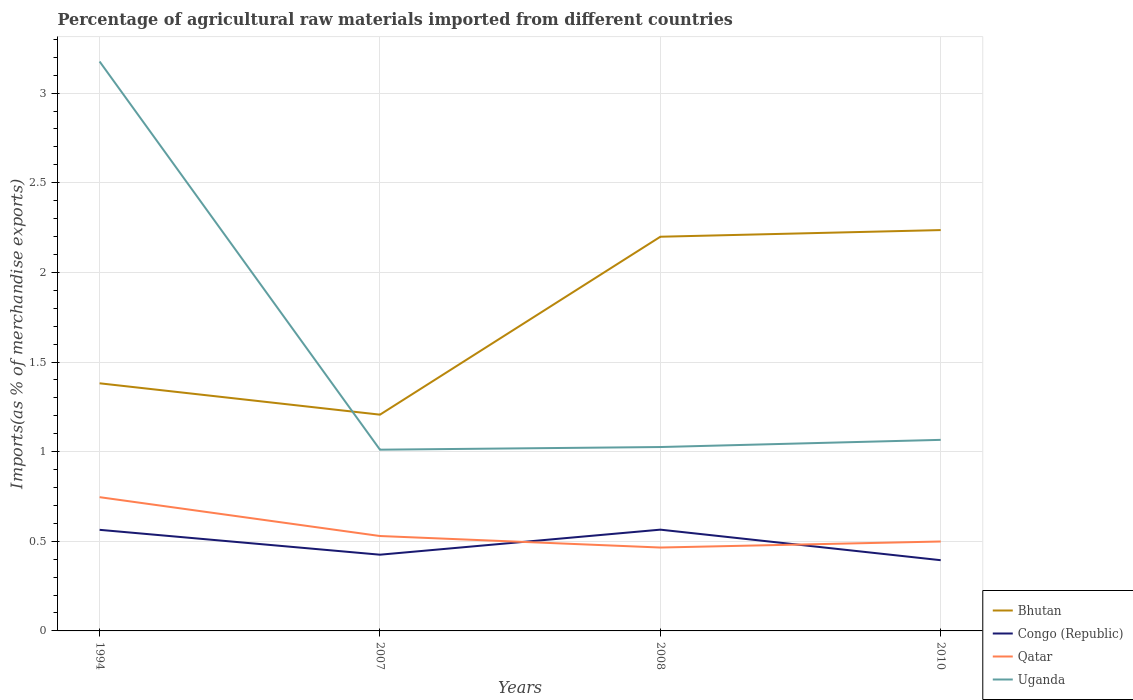Is the number of lines equal to the number of legend labels?
Your answer should be very brief. Yes. Across all years, what is the maximum percentage of imports to different countries in Qatar?
Provide a short and direct response. 0.47. In which year was the percentage of imports to different countries in Uganda maximum?
Make the answer very short. 2007. What is the total percentage of imports to different countries in Qatar in the graph?
Provide a succinct answer. 0.28. What is the difference between the highest and the second highest percentage of imports to different countries in Congo (Republic)?
Your answer should be compact. 0.17. How many lines are there?
Make the answer very short. 4. How many years are there in the graph?
Provide a short and direct response. 4. What is the difference between two consecutive major ticks on the Y-axis?
Provide a short and direct response. 0.5. How are the legend labels stacked?
Provide a succinct answer. Vertical. What is the title of the graph?
Offer a very short reply. Percentage of agricultural raw materials imported from different countries. Does "Hong Kong" appear as one of the legend labels in the graph?
Provide a short and direct response. No. What is the label or title of the X-axis?
Give a very brief answer. Years. What is the label or title of the Y-axis?
Keep it short and to the point. Imports(as % of merchandise exports). What is the Imports(as % of merchandise exports) in Bhutan in 1994?
Give a very brief answer. 1.38. What is the Imports(as % of merchandise exports) of Congo (Republic) in 1994?
Make the answer very short. 0.56. What is the Imports(as % of merchandise exports) in Qatar in 1994?
Give a very brief answer. 0.75. What is the Imports(as % of merchandise exports) of Uganda in 1994?
Offer a terse response. 3.18. What is the Imports(as % of merchandise exports) of Bhutan in 2007?
Provide a short and direct response. 1.21. What is the Imports(as % of merchandise exports) in Congo (Republic) in 2007?
Offer a terse response. 0.43. What is the Imports(as % of merchandise exports) of Qatar in 2007?
Provide a short and direct response. 0.53. What is the Imports(as % of merchandise exports) of Uganda in 2007?
Provide a succinct answer. 1.01. What is the Imports(as % of merchandise exports) of Bhutan in 2008?
Your answer should be compact. 2.2. What is the Imports(as % of merchandise exports) in Congo (Republic) in 2008?
Make the answer very short. 0.56. What is the Imports(as % of merchandise exports) in Qatar in 2008?
Give a very brief answer. 0.47. What is the Imports(as % of merchandise exports) of Uganda in 2008?
Provide a short and direct response. 1.03. What is the Imports(as % of merchandise exports) of Bhutan in 2010?
Provide a succinct answer. 2.24. What is the Imports(as % of merchandise exports) of Congo (Republic) in 2010?
Your response must be concise. 0.39. What is the Imports(as % of merchandise exports) of Qatar in 2010?
Keep it short and to the point. 0.5. What is the Imports(as % of merchandise exports) in Uganda in 2010?
Offer a very short reply. 1.07. Across all years, what is the maximum Imports(as % of merchandise exports) in Bhutan?
Provide a succinct answer. 2.24. Across all years, what is the maximum Imports(as % of merchandise exports) of Congo (Republic)?
Offer a terse response. 0.56. Across all years, what is the maximum Imports(as % of merchandise exports) in Qatar?
Offer a terse response. 0.75. Across all years, what is the maximum Imports(as % of merchandise exports) of Uganda?
Provide a short and direct response. 3.18. Across all years, what is the minimum Imports(as % of merchandise exports) of Bhutan?
Give a very brief answer. 1.21. Across all years, what is the minimum Imports(as % of merchandise exports) of Congo (Republic)?
Offer a terse response. 0.39. Across all years, what is the minimum Imports(as % of merchandise exports) of Qatar?
Your answer should be very brief. 0.47. Across all years, what is the minimum Imports(as % of merchandise exports) in Uganda?
Make the answer very short. 1.01. What is the total Imports(as % of merchandise exports) of Bhutan in the graph?
Your answer should be compact. 7.02. What is the total Imports(as % of merchandise exports) of Congo (Republic) in the graph?
Your response must be concise. 1.95. What is the total Imports(as % of merchandise exports) of Qatar in the graph?
Ensure brevity in your answer.  2.24. What is the total Imports(as % of merchandise exports) in Uganda in the graph?
Make the answer very short. 6.28. What is the difference between the Imports(as % of merchandise exports) of Bhutan in 1994 and that in 2007?
Make the answer very short. 0.17. What is the difference between the Imports(as % of merchandise exports) of Congo (Republic) in 1994 and that in 2007?
Your answer should be compact. 0.14. What is the difference between the Imports(as % of merchandise exports) of Qatar in 1994 and that in 2007?
Make the answer very short. 0.22. What is the difference between the Imports(as % of merchandise exports) in Uganda in 1994 and that in 2007?
Make the answer very short. 2.17. What is the difference between the Imports(as % of merchandise exports) of Bhutan in 1994 and that in 2008?
Your response must be concise. -0.82. What is the difference between the Imports(as % of merchandise exports) of Congo (Republic) in 1994 and that in 2008?
Offer a terse response. -0. What is the difference between the Imports(as % of merchandise exports) of Qatar in 1994 and that in 2008?
Your answer should be compact. 0.28. What is the difference between the Imports(as % of merchandise exports) of Uganda in 1994 and that in 2008?
Your response must be concise. 2.15. What is the difference between the Imports(as % of merchandise exports) of Bhutan in 1994 and that in 2010?
Keep it short and to the point. -0.85. What is the difference between the Imports(as % of merchandise exports) in Congo (Republic) in 1994 and that in 2010?
Give a very brief answer. 0.17. What is the difference between the Imports(as % of merchandise exports) in Qatar in 1994 and that in 2010?
Provide a short and direct response. 0.25. What is the difference between the Imports(as % of merchandise exports) in Uganda in 1994 and that in 2010?
Your answer should be very brief. 2.11. What is the difference between the Imports(as % of merchandise exports) in Bhutan in 2007 and that in 2008?
Make the answer very short. -0.99. What is the difference between the Imports(as % of merchandise exports) of Congo (Republic) in 2007 and that in 2008?
Ensure brevity in your answer.  -0.14. What is the difference between the Imports(as % of merchandise exports) in Qatar in 2007 and that in 2008?
Your answer should be very brief. 0.06. What is the difference between the Imports(as % of merchandise exports) in Uganda in 2007 and that in 2008?
Ensure brevity in your answer.  -0.01. What is the difference between the Imports(as % of merchandise exports) in Bhutan in 2007 and that in 2010?
Your answer should be compact. -1.03. What is the difference between the Imports(as % of merchandise exports) of Congo (Republic) in 2007 and that in 2010?
Ensure brevity in your answer.  0.03. What is the difference between the Imports(as % of merchandise exports) in Qatar in 2007 and that in 2010?
Your answer should be very brief. 0.03. What is the difference between the Imports(as % of merchandise exports) of Uganda in 2007 and that in 2010?
Offer a very short reply. -0.05. What is the difference between the Imports(as % of merchandise exports) in Bhutan in 2008 and that in 2010?
Offer a very short reply. -0.04. What is the difference between the Imports(as % of merchandise exports) of Congo (Republic) in 2008 and that in 2010?
Keep it short and to the point. 0.17. What is the difference between the Imports(as % of merchandise exports) of Qatar in 2008 and that in 2010?
Keep it short and to the point. -0.03. What is the difference between the Imports(as % of merchandise exports) of Uganda in 2008 and that in 2010?
Provide a short and direct response. -0.04. What is the difference between the Imports(as % of merchandise exports) of Bhutan in 1994 and the Imports(as % of merchandise exports) of Congo (Republic) in 2007?
Make the answer very short. 0.96. What is the difference between the Imports(as % of merchandise exports) of Bhutan in 1994 and the Imports(as % of merchandise exports) of Qatar in 2007?
Ensure brevity in your answer.  0.85. What is the difference between the Imports(as % of merchandise exports) of Bhutan in 1994 and the Imports(as % of merchandise exports) of Uganda in 2007?
Provide a succinct answer. 0.37. What is the difference between the Imports(as % of merchandise exports) in Congo (Republic) in 1994 and the Imports(as % of merchandise exports) in Qatar in 2007?
Offer a terse response. 0.03. What is the difference between the Imports(as % of merchandise exports) in Congo (Republic) in 1994 and the Imports(as % of merchandise exports) in Uganda in 2007?
Provide a short and direct response. -0.45. What is the difference between the Imports(as % of merchandise exports) of Qatar in 1994 and the Imports(as % of merchandise exports) of Uganda in 2007?
Keep it short and to the point. -0.26. What is the difference between the Imports(as % of merchandise exports) of Bhutan in 1994 and the Imports(as % of merchandise exports) of Congo (Republic) in 2008?
Provide a succinct answer. 0.82. What is the difference between the Imports(as % of merchandise exports) in Bhutan in 1994 and the Imports(as % of merchandise exports) in Qatar in 2008?
Your response must be concise. 0.92. What is the difference between the Imports(as % of merchandise exports) of Bhutan in 1994 and the Imports(as % of merchandise exports) of Uganda in 2008?
Your answer should be very brief. 0.36. What is the difference between the Imports(as % of merchandise exports) in Congo (Republic) in 1994 and the Imports(as % of merchandise exports) in Qatar in 2008?
Your response must be concise. 0.1. What is the difference between the Imports(as % of merchandise exports) in Congo (Republic) in 1994 and the Imports(as % of merchandise exports) in Uganda in 2008?
Provide a short and direct response. -0.46. What is the difference between the Imports(as % of merchandise exports) in Qatar in 1994 and the Imports(as % of merchandise exports) in Uganda in 2008?
Provide a short and direct response. -0.28. What is the difference between the Imports(as % of merchandise exports) in Bhutan in 1994 and the Imports(as % of merchandise exports) in Qatar in 2010?
Give a very brief answer. 0.88. What is the difference between the Imports(as % of merchandise exports) of Bhutan in 1994 and the Imports(as % of merchandise exports) of Uganda in 2010?
Your answer should be compact. 0.32. What is the difference between the Imports(as % of merchandise exports) in Congo (Republic) in 1994 and the Imports(as % of merchandise exports) in Qatar in 2010?
Provide a short and direct response. 0.07. What is the difference between the Imports(as % of merchandise exports) in Congo (Republic) in 1994 and the Imports(as % of merchandise exports) in Uganda in 2010?
Your answer should be very brief. -0.5. What is the difference between the Imports(as % of merchandise exports) in Qatar in 1994 and the Imports(as % of merchandise exports) in Uganda in 2010?
Provide a succinct answer. -0.32. What is the difference between the Imports(as % of merchandise exports) in Bhutan in 2007 and the Imports(as % of merchandise exports) in Congo (Republic) in 2008?
Provide a succinct answer. 0.64. What is the difference between the Imports(as % of merchandise exports) of Bhutan in 2007 and the Imports(as % of merchandise exports) of Qatar in 2008?
Your response must be concise. 0.74. What is the difference between the Imports(as % of merchandise exports) of Bhutan in 2007 and the Imports(as % of merchandise exports) of Uganda in 2008?
Keep it short and to the point. 0.18. What is the difference between the Imports(as % of merchandise exports) of Congo (Republic) in 2007 and the Imports(as % of merchandise exports) of Qatar in 2008?
Provide a short and direct response. -0.04. What is the difference between the Imports(as % of merchandise exports) in Congo (Republic) in 2007 and the Imports(as % of merchandise exports) in Uganda in 2008?
Your response must be concise. -0.6. What is the difference between the Imports(as % of merchandise exports) of Qatar in 2007 and the Imports(as % of merchandise exports) of Uganda in 2008?
Make the answer very short. -0.5. What is the difference between the Imports(as % of merchandise exports) in Bhutan in 2007 and the Imports(as % of merchandise exports) in Congo (Republic) in 2010?
Offer a terse response. 0.81. What is the difference between the Imports(as % of merchandise exports) in Bhutan in 2007 and the Imports(as % of merchandise exports) in Qatar in 2010?
Your answer should be compact. 0.71. What is the difference between the Imports(as % of merchandise exports) of Bhutan in 2007 and the Imports(as % of merchandise exports) of Uganda in 2010?
Offer a terse response. 0.14. What is the difference between the Imports(as % of merchandise exports) in Congo (Republic) in 2007 and the Imports(as % of merchandise exports) in Qatar in 2010?
Keep it short and to the point. -0.07. What is the difference between the Imports(as % of merchandise exports) in Congo (Republic) in 2007 and the Imports(as % of merchandise exports) in Uganda in 2010?
Offer a very short reply. -0.64. What is the difference between the Imports(as % of merchandise exports) in Qatar in 2007 and the Imports(as % of merchandise exports) in Uganda in 2010?
Your response must be concise. -0.54. What is the difference between the Imports(as % of merchandise exports) in Bhutan in 2008 and the Imports(as % of merchandise exports) in Congo (Republic) in 2010?
Provide a short and direct response. 1.8. What is the difference between the Imports(as % of merchandise exports) in Bhutan in 2008 and the Imports(as % of merchandise exports) in Uganda in 2010?
Give a very brief answer. 1.13. What is the difference between the Imports(as % of merchandise exports) of Congo (Republic) in 2008 and the Imports(as % of merchandise exports) of Qatar in 2010?
Make the answer very short. 0.07. What is the difference between the Imports(as % of merchandise exports) of Congo (Republic) in 2008 and the Imports(as % of merchandise exports) of Uganda in 2010?
Make the answer very short. -0.5. What is the difference between the Imports(as % of merchandise exports) of Qatar in 2008 and the Imports(as % of merchandise exports) of Uganda in 2010?
Keep it short and to the point. -0.6. What is the average Imports(as % of merchandise exports) of Bhutan per year?
Provide a short and direct response. 1.76. What is the average Imports(as % of merchandise exports) in Congo (Republic) per year?
Your response must be concise. 0.49. What is the average Imports(as % of merchandise exports) in Qatar per year?
Offer a very short reply. 0.56. What is the average Imports(as % of merchandise exports) in Uganda per year?
Your answer should be very brief. 1.57. In the year 1994, what is the difference between the Imports(as % of merchandise exports) of Bhutan and Imports(as % of merchandise exports) of Congo (Republic)?
Provide a succinct answer. 0.82. In the year 1994, what is the difference between the Imports(as % of merchandise exports) of Bhutan and Imports(as % of merchandise exports) of Qatar?
Your response must be concise. 0.64. In the year 1994, what is the difference between the Imports(as % of merchandise exports) of Bhutan and Imports(as % of merchandise exports) of Uganda?
Provide a succinct answer. -1.79. In the year 1994, what is the difference between the Imports(as % of merchandise exports) of Congo (Republic) and Imports(as % of merchandise exports) of Qatar?
Your answer should be very brief. -0.18. In the year 1994, what is the difference between the Imports(as % of merchandise exports) of Congo (Republic) and Imports(as % of merchandise exports) of Uganda?
Your answer should be very brief. -2.61. In the year 1994, what is the difference between the Imports(as % of merchandise exports) in Qatar and Imports(as % of merchandise exports) in Uganda?
Make the answer very short. -2.43. In the year 2007, what is the difference between the Imports(as % of merchandise exports) in Bhutan and Imports(as % of merchandise exports) in Congo (Republic)?
Your answer should be compact. 0.78. In the year 2007, what is the difference between the Imports(as % of merchandise exports) in Bhutan and Imports(as % of merchandise exports) in Qatar?
Ensure brevity in your answer.  0.68. In the year 2007, what is the difference between the Imports(as % of merchandise exports) of Bhutan and Imports(as % of merchandise exports) of Uganda?
Offer a very short reply. 0.2. In the year 2007, what is the difference between the Imports(as % of merchandise exports) of Congo (Republic) and Imports(as % of merchandise exports) of Qatar?
Your response must be concise. -0.1. In the year 2007, what is the difference between the Imports(as % of merchandise exports) of Congo (Republic) and Imports(as % of merchandise exports) of Uganda?
Provide a succinct answer. -0.59. In the year 2007, what is the difference between the Imports(as % of merchandise exports) of Qatar and Imports(as % of merchandise exports) of Uganda?
Provide a succinct answer. -0.48. In the year 2008, what is the difference between the Imports(as % of merchandise exports) in Bhutan and Imports(as % of merchandise exports) in Congo (Republic)?
Offer a very short reply. 1.63. In the year 2008, what is the difference between the Imports(as % of merchandise exports) in Bhutan and Imports(as % of merchandise exports) in Qatar?
Your response must be concise. 1.73. In the year 2008, what is the difference between the Imports(as % of merchandise exports) in Bhutan and Imports(as % of merchandise exports) in Uganda?
Your response must be concise. 1.17. In the year 2008, what is the difference between the Imports(as % of merchandise exports) in Congo (Republic) and Imports(as % of merchandise exports) in Qatar?
Offer a very short reply. 0.1. In the year 2008, what is the difference between the Imports(as % of merchandise exports) in Congo (Republic) and Imports(as % of merchandise exports) in Uganda?
Your answer should be compact. -0.46. In the year 2008, what is the difference between the Imports(as % of merchandise exports) in Qatar and Imports(as % of merchandise exports) in Uganda?
Ensure brevity in your answer.  -0.56. In the year 2010, what is the difference between the Imports(as % of merchandise exports) of Bhutan and Imports(as % of merchandise exports) of Congo (Republic)?
Provide a succinct answer. 1.84. In the year 2010, what is the difference between the Imports(as % of merchandise exports) in Bhutan and Imports(as % of merchandise exports) in Qatar?
Your response must be concise. 1.74. In the year 2010, what is the difference between the Imports(as % of merchandise exports) in Bhutan and Imports(as % of merchandise exports) in Uganda?
Ensure brevity in your answer.  1.17. In the year 2010, what is the difference between the Imports(as % of merchandise exports) in Congo (Republic) and Imports(as % of merchandise exports) in Qatar?
Your response must be concise. -0.1. In the year 2010, what is the difference between the Imports(as % of merchandise exports) of Congo (Republic) and Imports(as % of merchandise exports) of Uganda?
Ensure brevity in your answer.  -0.67. In the year 2010, what is the difference between the Imports(as % of merchandise exports) of Qatar and Imports(as % of merchandise exports) of Uganda?
Your answer should be compact. -0.57. What is the ratio of the Imports(as % of merchandise exports) in Bhutan in 1994 to that in 2007?
Provide a succinct answer. 1.15. What is the ratio of the Imports(as % of merchandise exports) of Congo (Republic) in 1994 to that in 2007?
Your answer should be compact. 1.33. What is the ratio of the Imports(as % of merchandise exports) in Qatar in 1994 to that in 2007?
Offer a terse response. 1.41. What is the ratio of the Imports(as % of merchandise exports) in Uganda in 1994 to that in 2007?
Keep it short and to the point. 3.14. What is the ratio of the Imports(as % of merchandise exports) in Bhutan in 1994 to that in 2008?
Offer a very short reply. 0.63. What is the ratio of the Imports(as % of merchandise exports) of Qatar in 1994 to that in 2008?
Your answer should be compact. 1.6. What is the ratio of the Imports(as % of merchandise exports) in Uganda in 1994 to that in 2008?
Offer a very short reply. 3.1. What is the ratio of the Imports(as % of merchandise exports) of Bhutan in 1994 to that in 2010?
Offer a terse response. 0.62. What is the ratio of the Imports(as % of merchandise exports) in Congo (Republic) in 1994 to that in 2010?
Keep it short and to the point. 1.43. What is the ratio of the Imports(as % of merchandise exports) of Qatar in 1994 to that in 2010?
Make the answer very short. 1.5. What is the ratio of the Imports(as % of merchandise exports) of Uganda in 1994 to that in 2010?
Your response must be concise. 2.98. What is the ratio of the Imports(as % of merchandise exports) of Bhutan in 2007 to that in 2008?
Provide a succinct answer. 0.55. What is the ratio of the Imports(as % of merchandise exports) of Congo (Republic) in 2007 to that in 2008?
Make the answer very short. 0.75. What is the ratio of the Imports(as % of merchandise exports) in Qatar in 2007 to that in 2008?
Your answer should be compact. 1.14. What is the ratio of the Imports(as % of merchandise exports) in Uganda in 2007 to that in 2008?
Offer a terse response. 0.99. What is the ratio of the Imports(as % of merchandise exports) in Bhutan in 2007 to that in 2010?
Make the answer very short. 0.54. What is the ratio of the Imports(as % of merchandise exports) in Congo (Republic) in 2007 to that in 2010?
Make the answer very short. 1.08. What is the ratio of the Imports(as % of merchandise exports) of Qatar in 2007 to that in 2010?
Give a very brief answer. 1.06. What is the ratio of the Imports(as % of merchandise exports) of Uganda in 2007 to that in 2010?
Your answer should be compact. 0.95. What is the ratio of the Imports(as % of merchandise exports) of Bhutan in 2008 to that in 2010?
Ensure brevity in your answer.  0.98. What is the ratio of the Imports(as % of merchandise exports) of Congo (Republic) in 2008 to that in 2010?
Offer a terse response. 1.43. What is the ratio of the Imports(as % of merchandise exports) in Qatar in 2008 to that in 2010?
Keep it short and to the point. 0.93. What is the ratio of the Imports(as % of merchandise exports) in Uganda in 2008 to that in 2010?
Ensure brevity in your answer.  0.96. What is the difference between the highest and the second highest Imports(as % of merchandise exports) of Bhutan?
Provide a short and direct response. 0.04. What is the difference between the highest and the second highest Imports(as % of merchandise exports) of Qatar?
Offer a terse response. 0.22. What is the difference between the highest and the second highest Imports(as % of merchandise exports) of Uganda?
Keep it short and to the point. 2.11. What is the difference between the highest and the lowest Imports(as % of merchandise exports) in Bhutan?
Make the answer very short. 1.03. What is the difference between the highest and the lowest Imports(as % of merchandise exports) in Congo (Republic)?
Make the answer very short. 0.17. What is the difference between the highest and the lowest Imports(as % of merchandise exports) of Qatar?
Give a very brief answer. 0.28. What is the difference between the highest and the lowest Imports(as % of merchandise exports) of Uganda?
Your answer should be very brief. 2.17. 